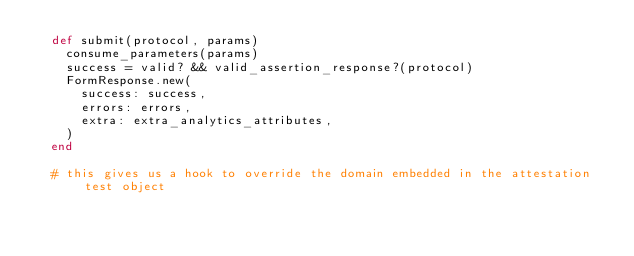Convert code to text. <code><loc_0><loc_0><loc_500><loc_500><_Ruby_>  def submit(protocol, params)
    consume_parameters(params)
    success = valid? && valid_assertion_response?(protocol)
    FormResponse.new(
      success: success,
      errors: errors,
      extra: extra_analytics_attributes,
    )
  end

  # this gives us a hook to override the domain embedded in the attestation test object</code> 